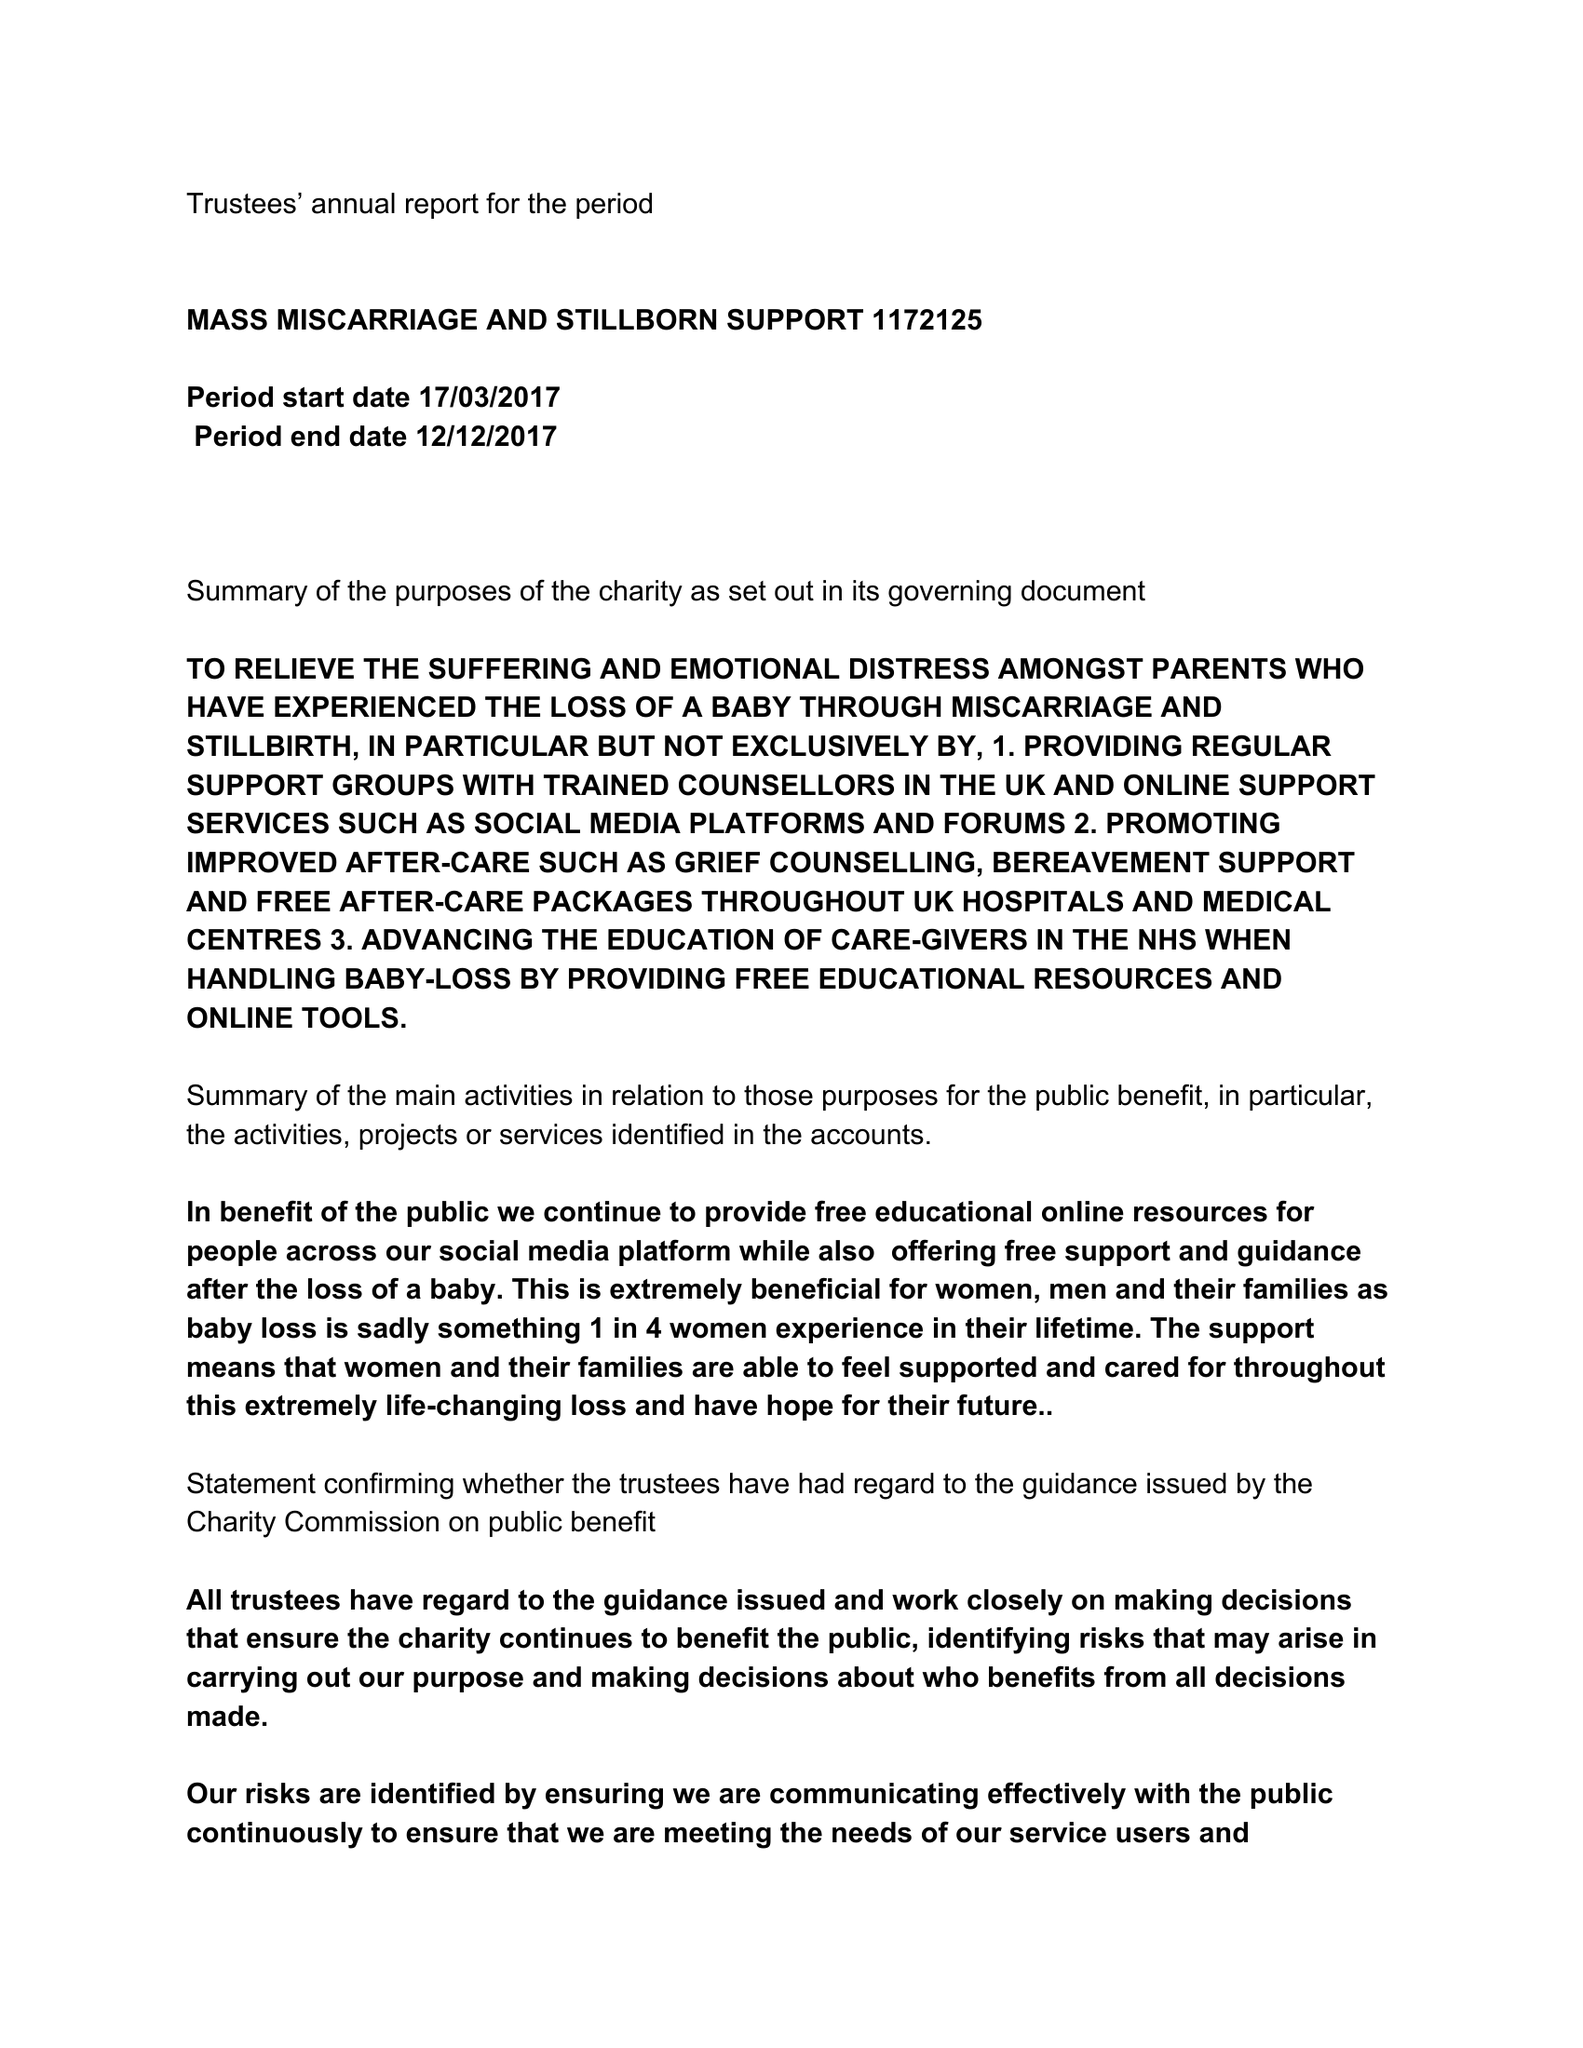What is the value for the report_date?
Answer the question using a single word or phrase. 2017-12-12 